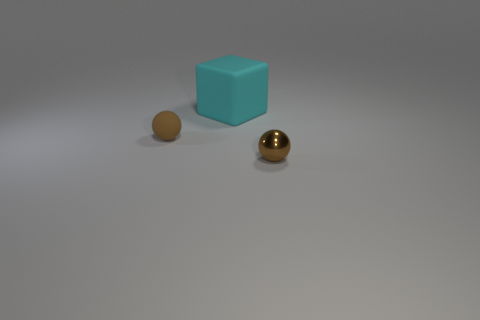There is a large cyan object behind the rubber object that is left of the rubber cube; how many tiny brown objects are in front of it?
Ensure brevity in your answer.  2. What number of brown objects are in front of the tiny matte sphere?
Offer a very short reply. 1. There is a matte thing that is the same shape as the brown metallic thing; what is its color?
Offer a terse response. Brown. What is the material of the object that is both to the right of the small brown matte object and in front of the big cyan rubber object?
Your answer should be compact. Metal. Is the size of the brown metallic sphere in front of the cyan block the same as the small rubber ball?
Your response must be concise. Yes. What is the material of the cube?
Keep it short and to the point. Rubber. There is a small ball to the left of the small metallic sphere; what is its color?
Make the answer very short. Brown. What number of large objects are either green metallic balls or brown rubber objects?
Offer a terse response. 0. There is a rubber thing that is on the left side of the matte cube; is it the same color as the object right of the cyan cube?
Your response must be concise. Yes. What number of other objects are there of the same color as the block?
Provide a succinct answer. 0. 